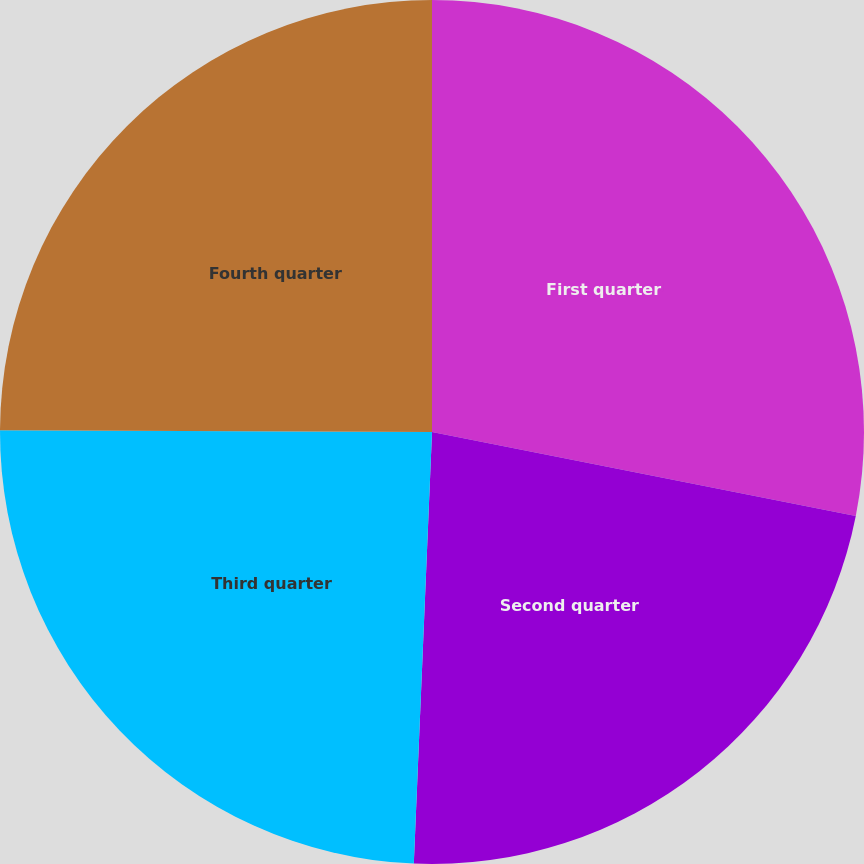<chart> <loc_0><loc_0><loc_500><loc_500><pie_chart><fcel>First quarter<fcel>Second quarter<fcel>Third quarter<fcel>Fourth quarter<nl><fcel>28.11%<fcel>22.56%<fcel>24.39%<fcel>24.94%<nl></chart> 